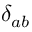<formula> <loc_0><loc_0><loc_500><loc_500>\delta _ { a b }</formula> 